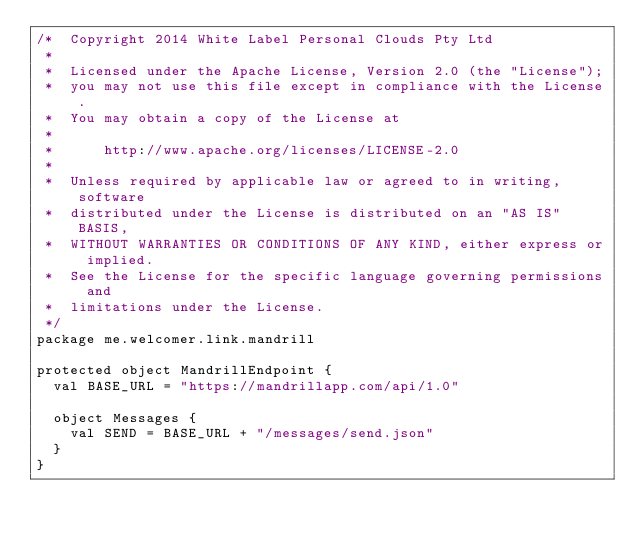Convert code to text. <code><loc_0><loc_0><loc_500><loc_500><_Scala_>/*  Copyright 2014 White Label Personal Clouds Pty Ltd
 *
 *  Licensed under the Apache License, Version 2.0 (the "License");
 *  you may not use this file except in compliance with the License.
 *  You may obtain a copy of the License at
 *
 *      http://www.apache.org/licenses/LICENSE-2.0
 *
 *  Unless required by applicable law or agreed to in writing, software
 *  distributed under the License is distributed on an "AS IS" BASIS,
 *  WITHOUT WARRANTIES OR CONDITIONS OF ANY KIND, either express or implied.
 *  See the License for the specific language governing permissions and
 *  limitations under the License. 
 */
package me.welcomer.link.mandrill

protected object MandrillEndpoint {
  val BASE_URL = "https://mandrillapp.com/api/1.0"

  object Messages {
    val SEND = BASE_URL + "/messages/send.json"
  }
}</code> 